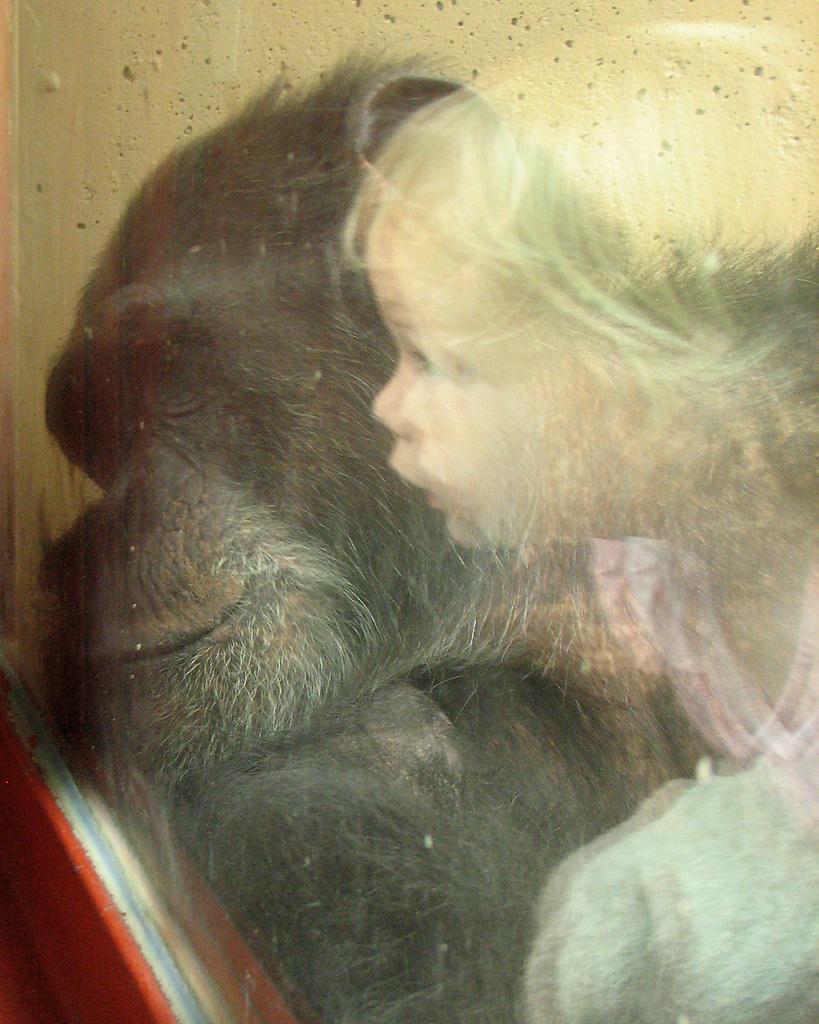How would you summarize this image in a sentence or two? This picture consists of a painting , in the painting I can see a baby image and an animal image. 